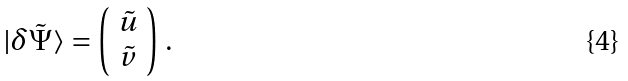<formula> <loc_0><loc_0><loc_500><loc_500>| \delta \tilde { \Psi } \rangle = \left ( \begin{array} { c } \tilde { u } \\ \tilde { v } \end{array} \right ) \, .</formula> 